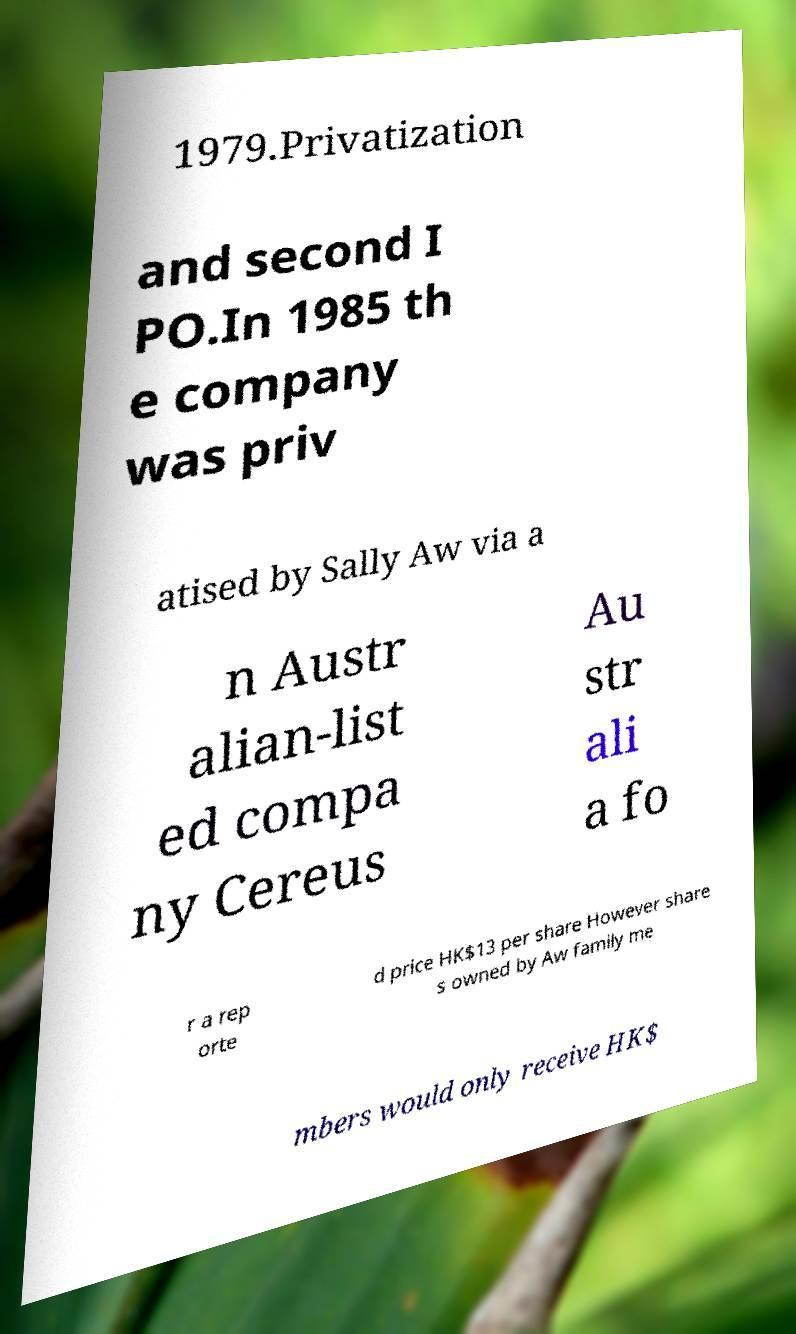Could you extract and type out the text from this image? 1979.Privatization and second I PO.In 1985 th e company was priv atised by Sally Aw via a n Austr alian-list ed compa ny Cereus Au str ali a fo r a rep orte d price HK$13 per share However share s owned by Aw family me mbers would only receive HK$ 